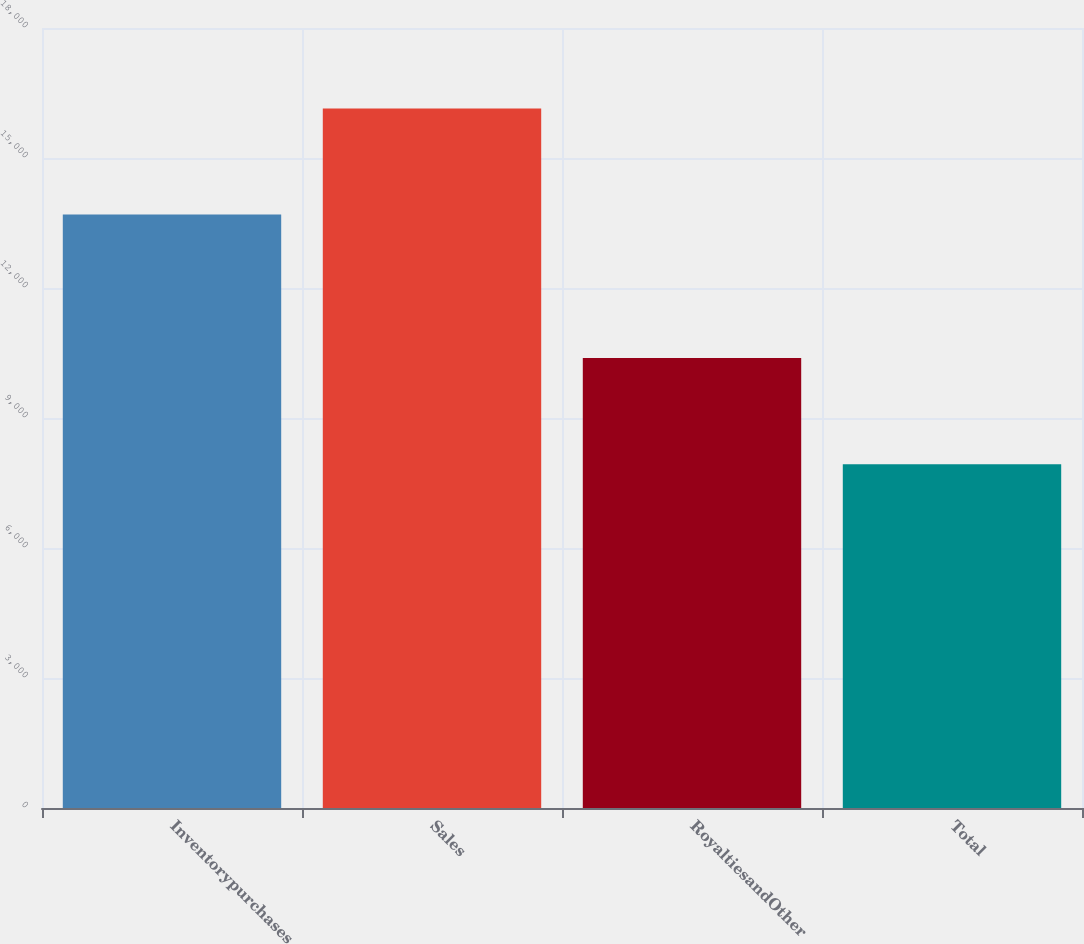Convert chart to OTSL. <chart><loc_0><loc_0><loc_500><loc_500><bar_chart><fcel>Inventorypurchases<fcel>Sales<fcel>RoyaltiesandOther<fcel>Total<nl><fcel>13695<fcel>16144<fcel>10383<fcel>7934<nl></chart> 